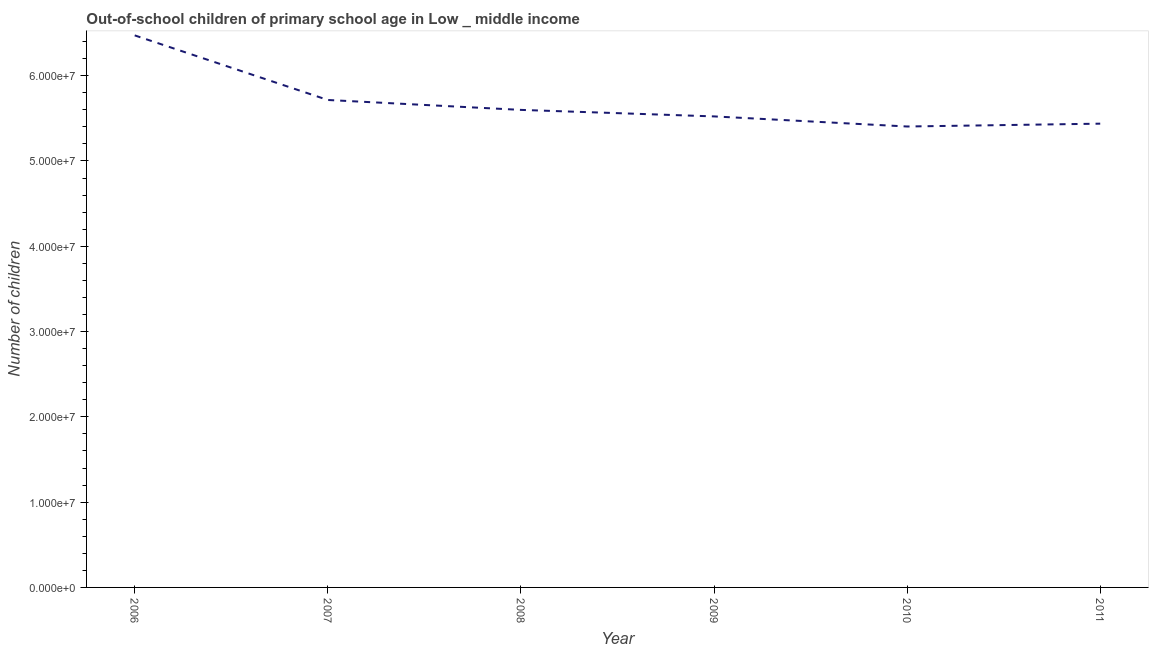What is the number of out-of-school children in 2006?
Ensure brevity in your answer.  6.47e+07. Across all years, what is the maximum number of out-of-school children?
Ensure brevity in your answer.  6.47e+07. Across all years, what is the minimum number of out-of-school children?
Ensure brevity in your answer.  5.40e+07. What is the sum of the number of out-of-school children?
Keep it short and to the point. 3.42e+08. What is the difference between the number of out-of-school children in 2008 and 2009?
Your answer should be very brief. 7.64e+05. What is the average number of out-of-school children per year?
Give a very brief answer. 5.69e+07. What is the median number of out-of-school children?
Ensure brevity in your answer.  5.56e+07. What is the ratio of the number of out-of-school children in 2010 to that in 2011?
Provide a short and direct response. 0.99. Is the difference between the number of out-of-school children in 2006 and 2007 greater than the difference between any two years?
Ensure brevity in your answer.  No. What is the difference between the highest and the second highest number of out-of-school children?
Provide a succinct answer. 7.57e+06. What is the difference between the highest and the lowest number of out-of-school children?
Offer a terse response. 1.07e+07. In how many years, is the number of out-of-school children greater than the average number of out-of-school children taken over all years?
Offer a very short reply. 2. Does the number of out-of-school children monotonically increase over the years?
Your answer should be very brief. No. How many years are there in the graph?
Your answer should be very brief. 6. Are the values on the major ticks of Y-axis written in scientific E-notation?
Your answer should be compact. Yes. Does the graph contain any zero values?
Your response must be concise. No. Does the graph contain grids?
Offer a very short reply. No. What is the title of the graph?
Provide a succinct answer. Out-of-school children of primary school age in Low _ middle income. What is the label or title of the X-axis?
Keep it short and to the point. Year. What is the label or title of the Y-axis?
Offer a terse response. Number of children. What is the Number of children in 2006?
Ensure brevity in your answer.  6.47e+07. What is the Number of children in 2007?
Keep it short and to the point. 5.72e+07. What is the Number of children in 2008?
Give a very brief answer. 5.60e+07. What is the Number of children of 2009?
Give a very brief answer. 5.52e+07. What is the Number of children of 2010?
Your answer should be compact. 5.40e+07. What is the Number of children in 2011?
Keep it short and to the point. 5.44e+07. What is the difference between the Number of children in 2006 and 2007?
Your answer should be compact. 7.57e+06. What is the difference between the Number of children in 2006 and 2008?
Make the answer very short. 8.74e+06. What is the difference between the Number of children in 2006 and 2009?
Make the answer very short. 9.50e+06. What is the difference between the Number of children in 2006 and 2010?
Your answer should be very brief. 1.07e+07. What is the difference between the Number of children in 2006 and 2011?
Ensure brevity in your answer.  1.04e+07. What is the difference between the Number of children in 2007 and 2008?
Give a very brief answer. 1.16e+06. What is the difference between the Number of children in 2007 and 2009?
Provide a short and direct response. 1.93e+06. What is the difference between the Number of children in 2007 and 2010?
Make the answer very short. 3.11e+06. What is the difference between the Number of children in 2007 and 2011?
Your response must be concise. 2.78e+06. What is the difference between the Number of children in 2008 and 2009?
Make the answer very short. 7.64e+05. What is the difference between the Number of children in 2008 and 2010?
Keep it short and to the point. 1.95e+06. What is the difference between the Number of children in 2008 and 2011?
Your answer should be very brief. 1.61e+06. What is the difference between the Number of children in 2009 and 2010?
Provide a short and direct response. 1.18e+06. What is the difference between the Number of children in 2009 and 2011?
Provide a succinct answer. 8.51e+05. What is the difference between the Number of children in 2010 and 2011?
Provide a short and direct response. -3.32e+05. What is the ratio of the Number of children in 2006 to that in 2007?
Offer a terse response. 1.13. What is the ratio of the Number of children in 2006 to that in 2008?
Offer a terse response. 1.16. What is the ratio of the Number of children in 2006 to that in 2009?
Keep it short and to the point. 1.17. What is the ratio of the Number of children in 2006 to that in 2010?
Provide a succinct answer. 1.2. What is the ratio of the Number of children in 2006 to that in 2011?
Make the answer very short. 1.19. What is the ratio of the Number of children in 2007 to that in 2009?
Your answer should be compact. 1.03. What is the ratio of the Number of children in 2007 to that in 2010?
Your answer should be very brief. 1.06. What is the ratio of the Number of children in 2007 to that in 2011?
Your answer should be compact. 1.05. What is the ratio of the Number of children in 2008 to that in 2009?
Your response must be concise. 1.01. What is the ratio of the Number of children in 2008 to that in 2010?
Keep it short and to the point. 1.04. What is the ratio of the Number of children in 2008 to that in 2011?
Offer a very short reply. 1.03. What is the ratio of the Number of children in 2009 to that in 2010?
Provide a succinct answer. 1.02. What is the ratio of the Number of children in 2010 to that in 2011?
Your answer should be compact. 0.99. 